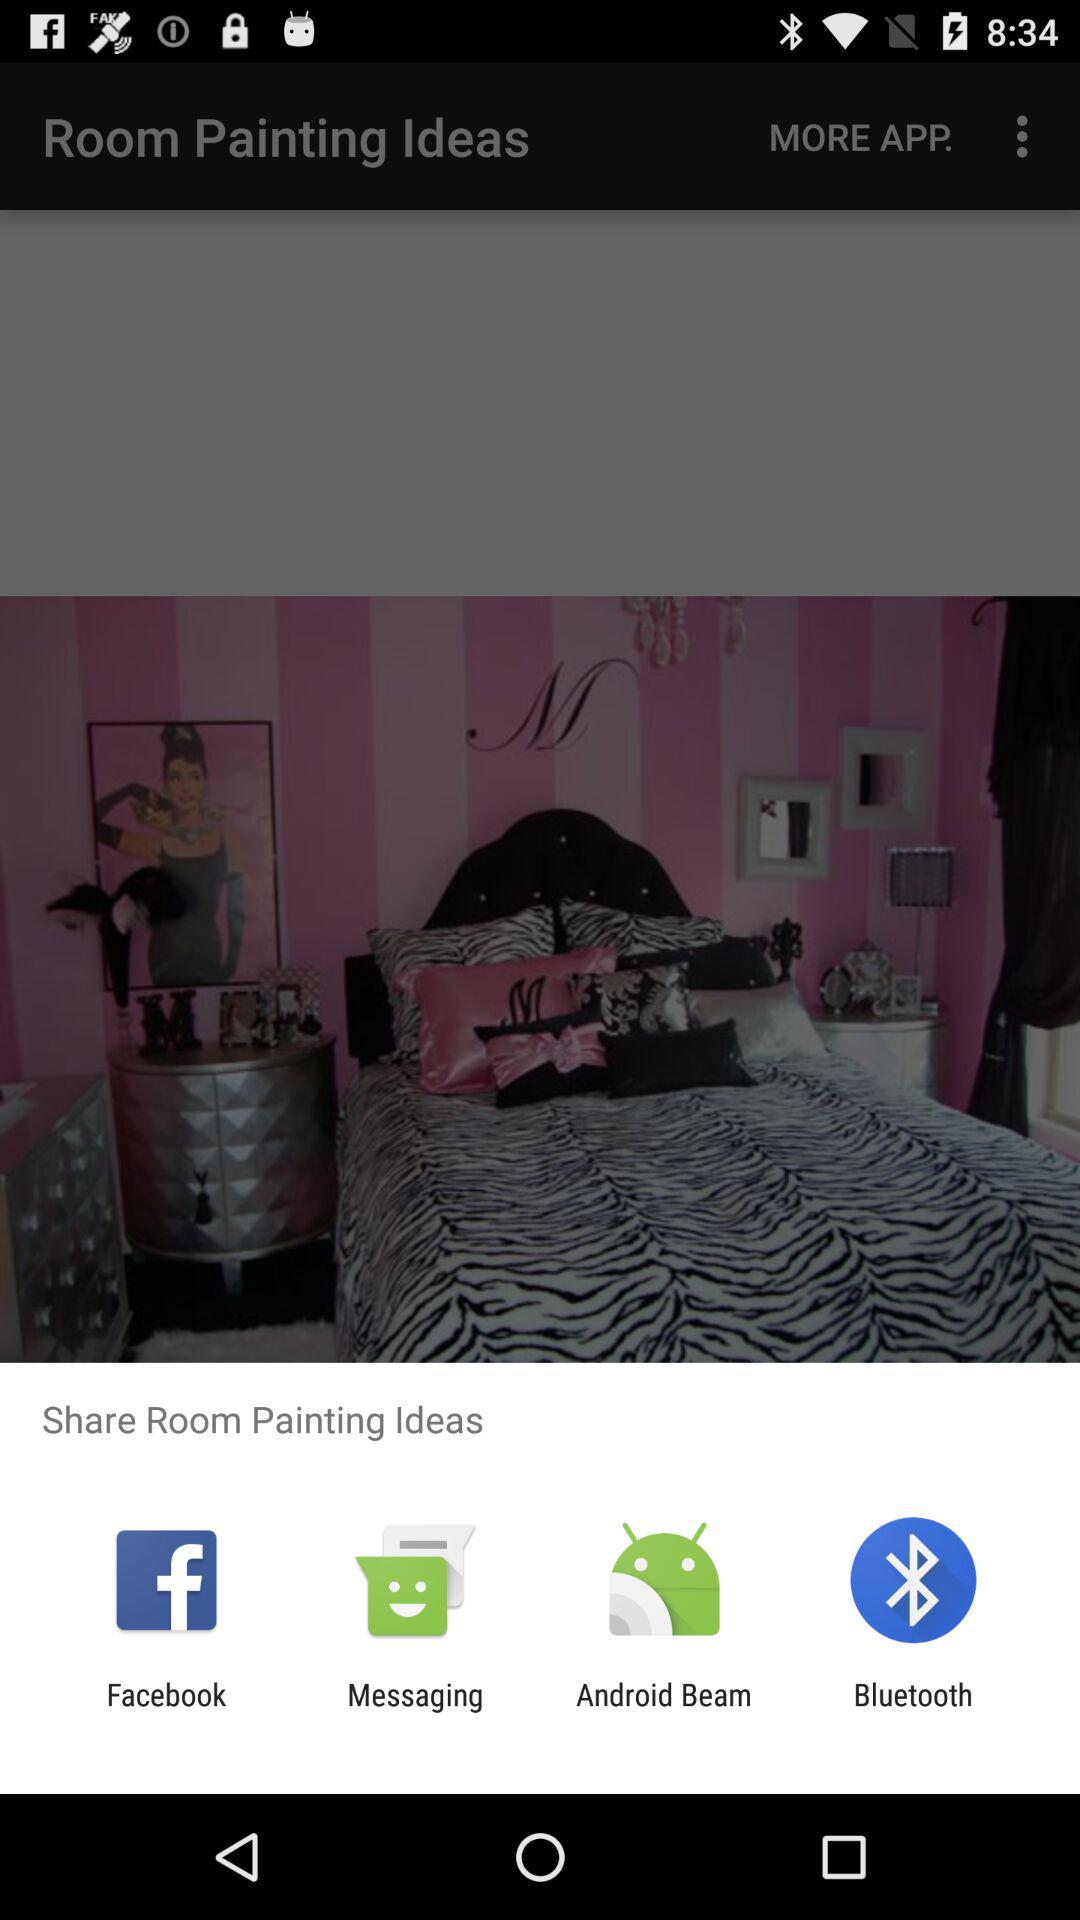Which apps are provided in "MORE APP."?
When the provided information is insufficient, respond with <no answer>. <no answer> 